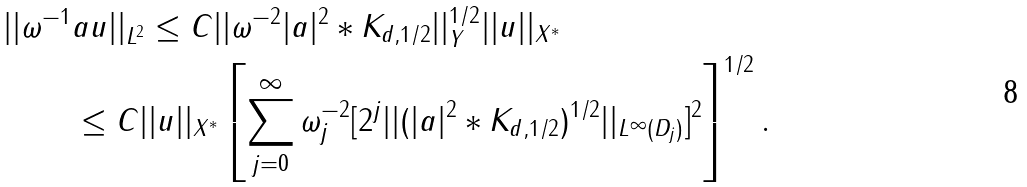Convert formula to latex. <formula><loc_0><loc_0><loc_500><loc_500>| | \omega ^ { - 1 } & a u | | _ { L ^ { 2 } } \leq C | | \omega ^ { - 2 } | a | ^ { 2 } \ast K _ { d , 1 / 2 } | | _ { Y } ^ { 1 / 2 } | | u | | _ { X ^ { \ast } } \\ & \leq C | | u | | _ { X ^ { \ast } } \left [ \sum _ { j = 0 } ^ { \infty } \omega _ { j } ^ { - 2 } [ 2 ^ { j } | | ( | a | ^ { 2 } \ast K _ { d , 1 / 2 } ) ^ { 1 / 2 } | | _ { L ^ { \infty } ( D _ { j } ) } ] ^ { 2 } \right ] ^ { 1 / 2 } .</formula> 